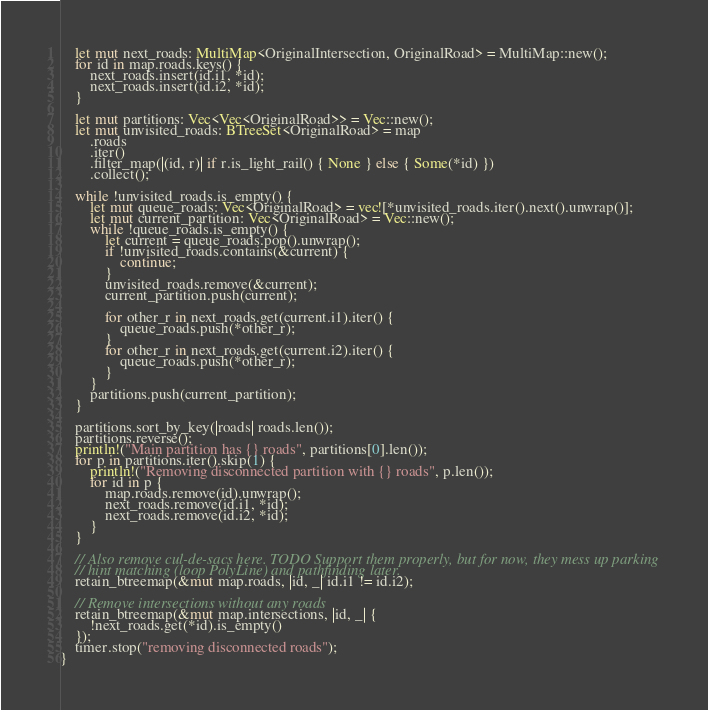Convert code to text. <code><loc_0><loc_0><loc_500><loc_500><_Rust_>
    let mut next_roads: MultiMap<OriginalIntersection, OriginalRoad> = MultiMap::new();
    for id in map.roads.keys() {
        next_roads.insert(id.i1, *id);
        next_roads.insert(id.i2, *id);
    }

    let mut partitions: Vec<Vec<OriginalRoad>> = Vec::new();
    let mut unvisited_roads: BTreeSet<OriginalRoad> = map
        .roads
        .iter()
        .filter_map(|(id, r)| if r.is_light_rail() { None } else { Some(*id) })
        .collect();

    while !unvisited_roads.is_empty() {
        let mut queue_roads: Vec<OriginalRoad> = vec![*unvisited_roads.iter().next().unwrap()];
        let mut current_partition: Vec<OriginalRoad> = Vec::new();
        while !queue_roads.is_empty() {
            let current = queue_roads.pop().unwrap();
            if !unvisited_roads.contains(&current) {
                continue;
            }
            unvisited_roads.remove(&current);
            current_partition.push(current);

            for other_r in next_roads.get(current.i1).iter() {
                queue_roads.push(*other_r);
            }
            for other_r in next_roads.get(current.i2).iter() {
                queue_roads.push(*other_r);
            }
        }
        partitions.push(current_partition);
    }

    partitions.sort_by_key(|roads| roads.len());
    partitions.reverse();
    println!("Main partition has {} roads", partitions[0].len());
    for p in partitions.iter().skip(1) {
        println!("Removing disconnected partition with {} roads", p.len());
        for id in p {
            map.roads.remove(id).unwrap();
            next_roads.remove(id.i1, *id);
            next_roads.remove(id.i2, *id);
        }
    }

    // Also remove cul-de-sacs here. TODO Support them properly, but for now, they mess up parking
    // hint matching (loop PolyLine) and pathfinding later.
    retain_btreemap(&mut map.roads, |id, _| id.i1 != id.i2);

    // Remove intersections without any roads
    retain_btreemap(&mut map.intersections, |id, _| {
        !next_roads.get(*id).is_empty()
    });
    timer.stop("removing disconnected roads");
}
</code> 